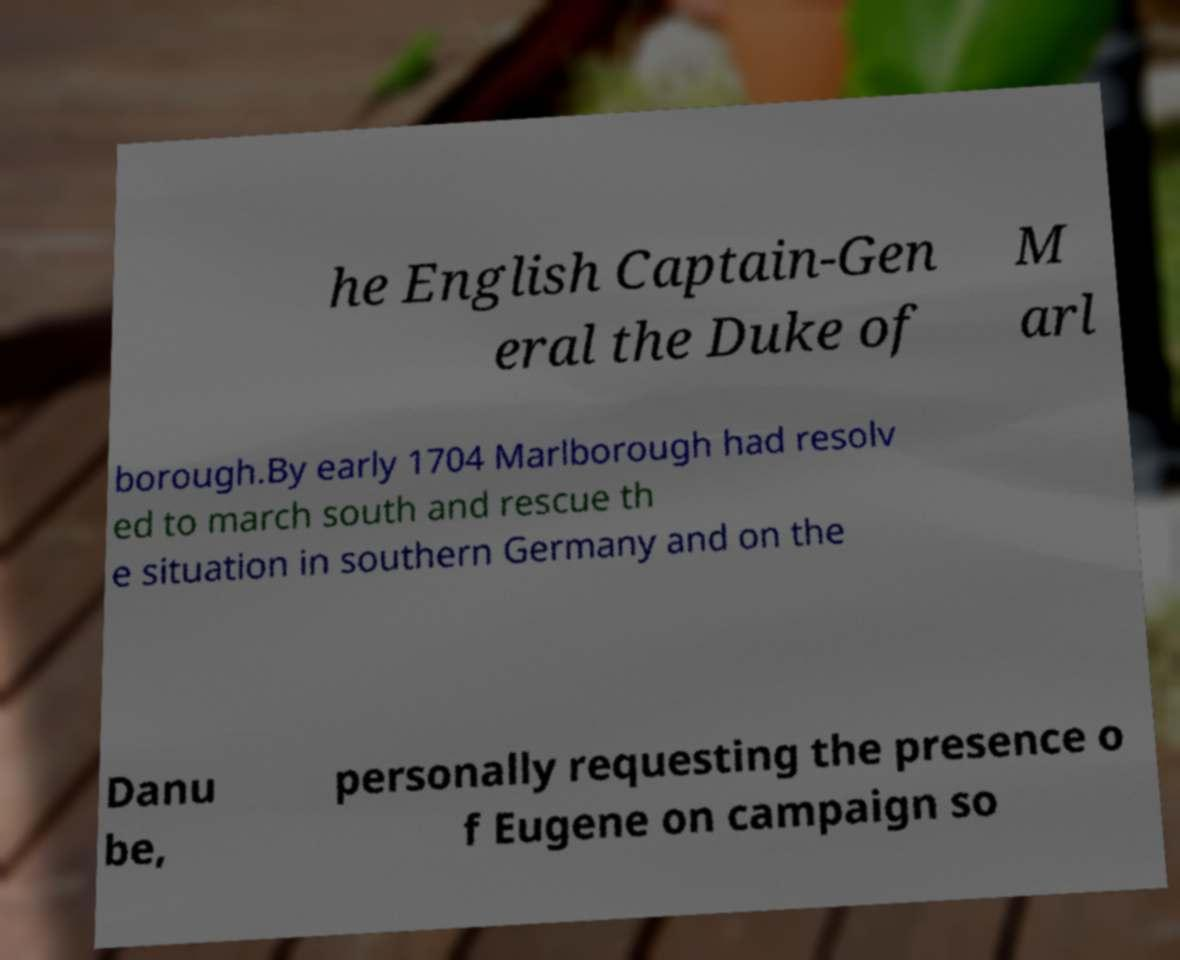Could you assist in decoding the text presented in this image and type it out clearly? he English Captain-Gen eral the Duke of M arl borough.By early 1704 Marlborough had resolv ed to march south and rescue th e situation in southern Germany and on the Danu be, personally requesting the presence o f Eugene on campaign so 